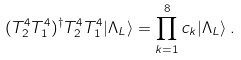<formula> <loc_0><loc_0><loc_500><loc_500>( T _ { 2 } ^ { 4 } T _ { 1 } ^ { 4 } ) ^ { \dagger } T _ { 2 } ^ { 4 } T ^ { 4 } _ { 1 } | \Lambda _ { L } \rangle = \prod _ { k = 1 } ^ { 8 } c _ { k } | \Lambda _ { L } \rangle \, .</formula> 